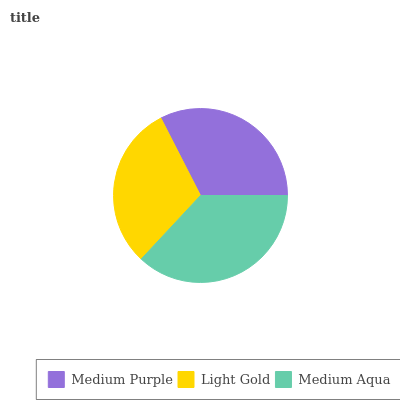Is Light Gold the minimum?
Answer yes or no. Yes. Is Medium Aqua the maximum?
Answer yes or no. Yes. Is Medium Aqua the minimum?
Answer yes or no. No. Is Light Gold the maximum?
Answer yes or no. No. Is Medium Aqua greater than Light Gold?
Answer yes or no. Yes. Is Light Gold less than Medium Aqua?
Answer yes or no. Yes. Is Light Gold greater than Medium Aqua?
Answer yes or no. No. Is Medium Aqua less than Light Gold?
Answer yes or no. No. Is Medium Purple the high median?
Answer yes or no. Yes. Is Medium Purple the low median?
Answer yes or no. Yes. Is Light Gold the high median?
Answer yes or no. No. Is Light Gold the low median?
Answer yes or no. No. 